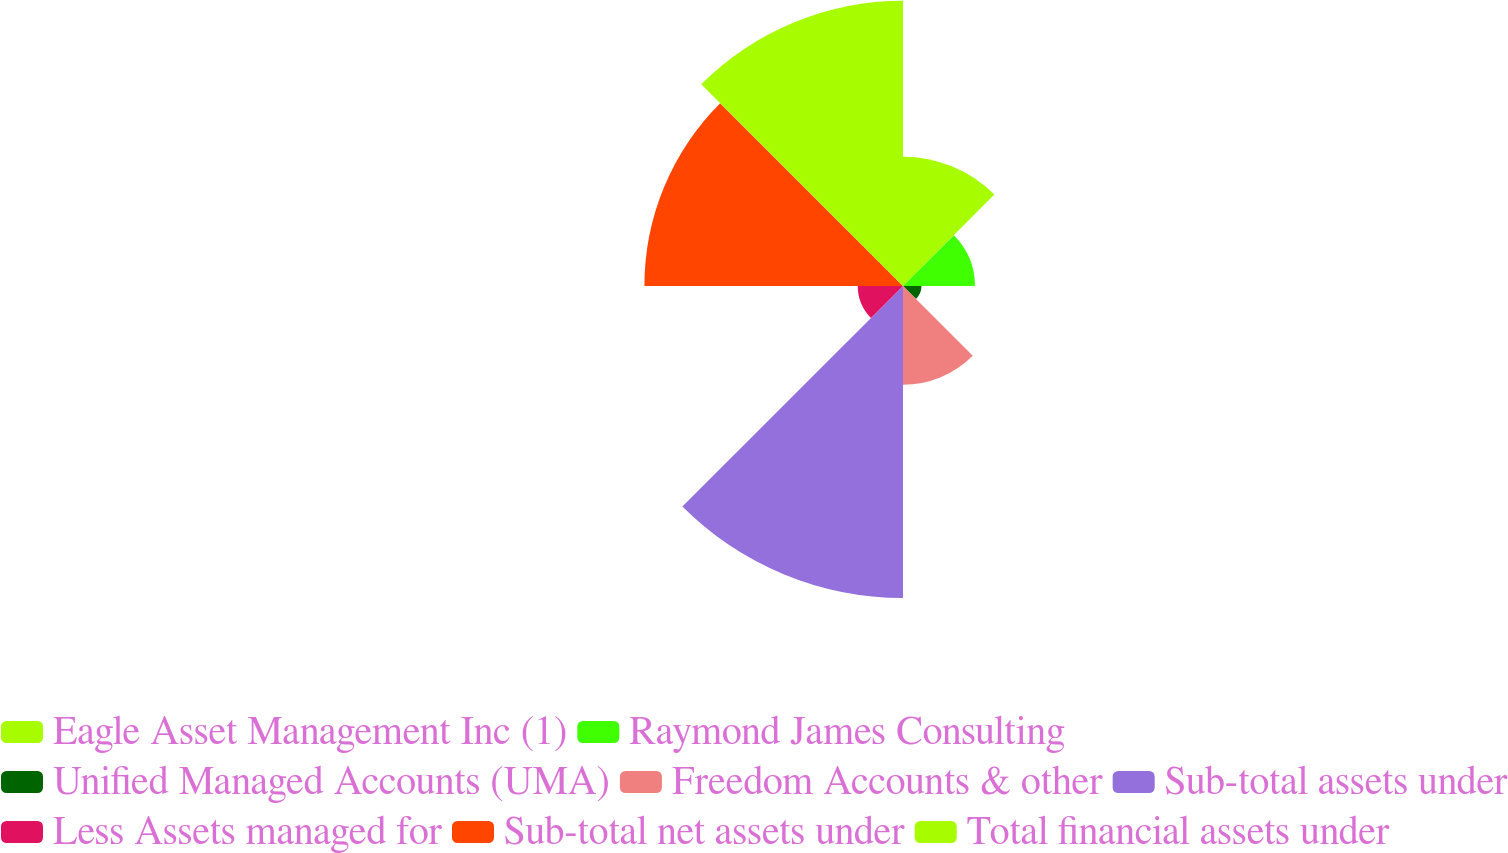Convert chart to OTSL. <chart><loc_0><loc_0><loc_500><loc_500><pie_chart><fcel>Eagle Asset Management Inc (1)<fcel>Raymond James Consulting<fcel>Unified Managed Accounts (UMA)<fcel>Freedom Accounts & other<fcel>Sub-total assets under<fcel>Less Assets managed for<fcel>Sub-total net assets under<fcel>Total financial assets under<nl><fcel>10.6%<fcel>5.9%<fcel>1.51%<fcel>8.09%<fcel>25.59%<fcel>3.71%<fcel>21.21%<fcel>23.4%<nl></chart> 